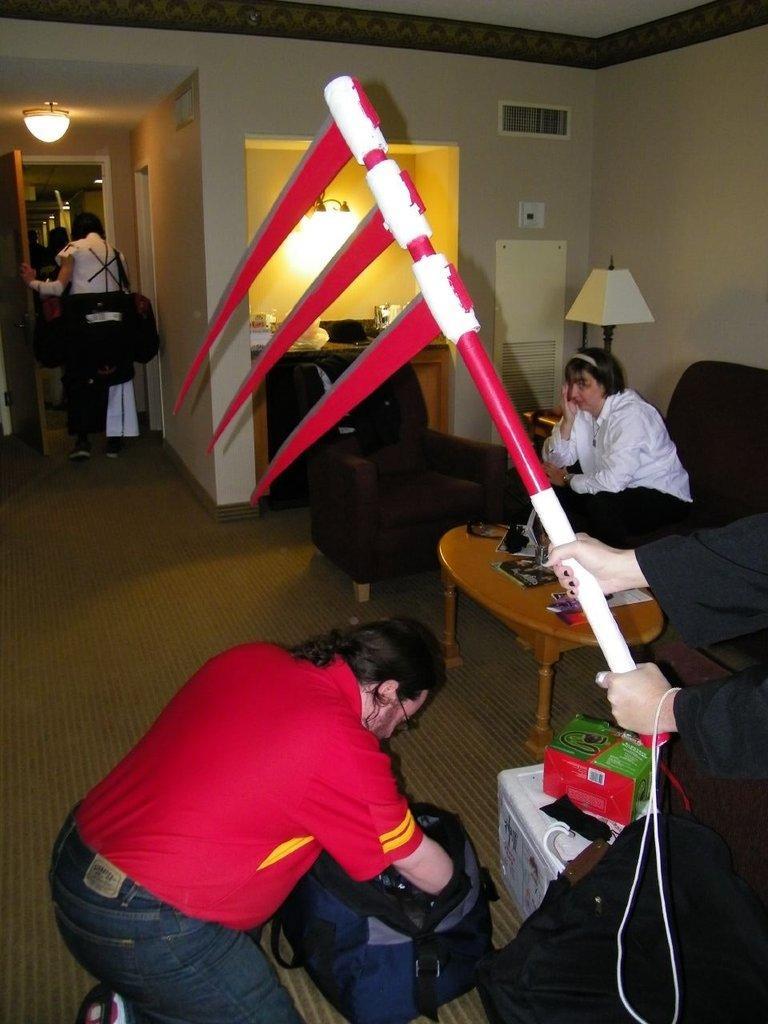In one or two sentences, can you explain what this image depicts? The image is taken in the room. On the right side of the image we can see a person's hand holding a weapon. At the bottom there is a man sitting on the floor and we can see a bag. On the left there is a person. In the background there are sofas and we can see a lady sitting on the sofa. There is a table. We can see a door, light, wall and a lamp. 